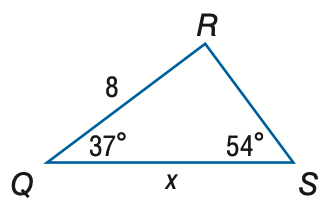Question: Find x. Round to the nearest tenth.
Choices:
A. 6.5
B. 9.9
C. 10.8
D. 13.3
Answer with the letter. Answer: B 